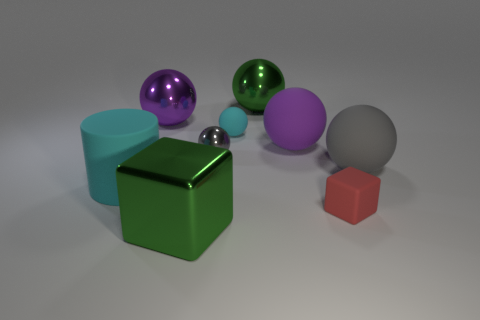Subtract 3 balls. How many balls are left? 3 Subtract all green spheres. How many spheres are left? 5 Subtract all small gray spheres. How many spheres are left? 5 Subtract all red spheres. Subtract all yellow blocks. How many spheres are left? 6 Add 1 blue rubber blocks. How many objects exist? 10 Subtract all cubes. How many objects are left? 7 Add 7 small gray shiny balls. How many small gray shiny balls are left? 8 Add 9 big purple matte spheres. How many big purple matte spheres exist? 10 Subtract 1 purple balls. How many objects are left? 8 Subtract all blue objects. Subtract all gray shiny things. How many objects are left? 8 